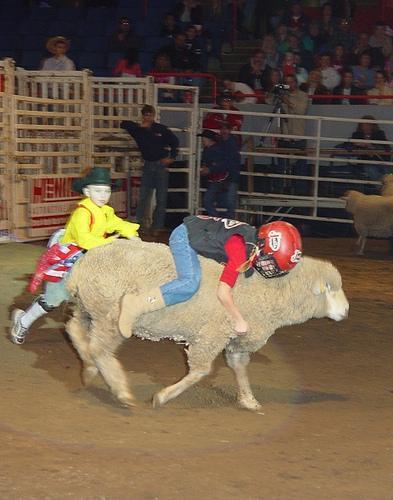How many little boys are in this picture?
Give a very brief answer. 2. How many people are there?
Give a very brief answer. 6. How many dogs are in the car?
Give a very brief answer. 0. 